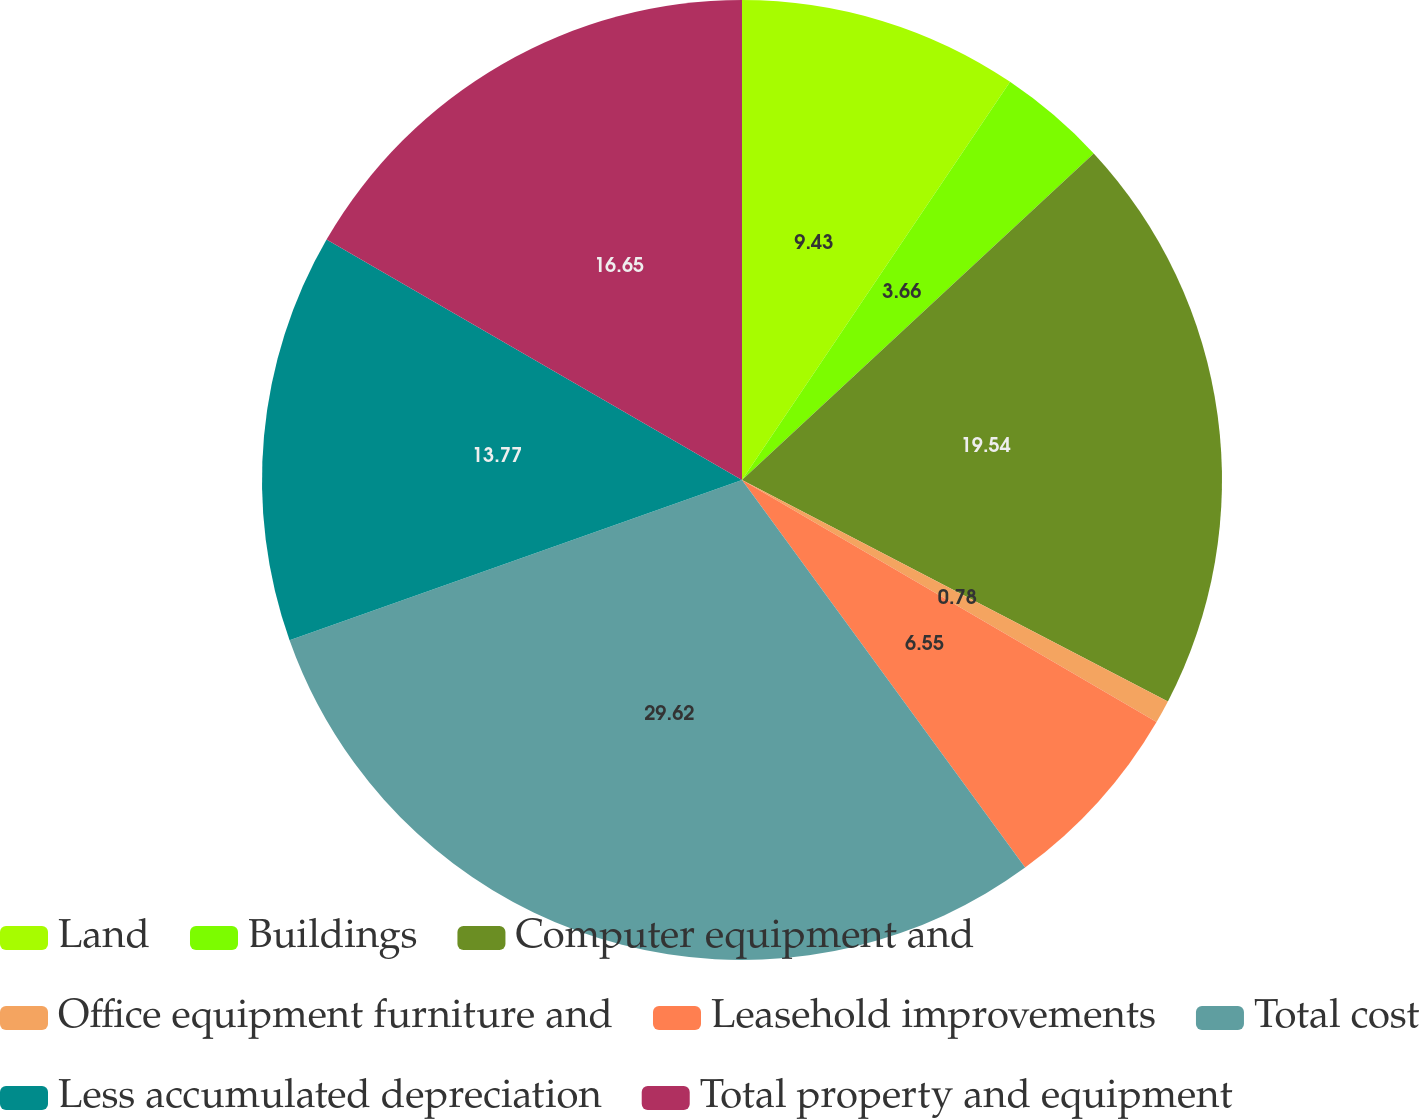Convert chart to OTSL. <chart><loc_0><loc_0><loc_500><loc_500><pie_chart><fcel>Land<fcel>Buildings<fcel>Computer equipment and<fcel>Office equipment furniture and<fcel>Leasehold improvements<fcel>Total cost<fcel>Less accumulated depreciation<fcel>Total property and equipment<nl><fcel>9.43%<fcel>3.66%<fcel>19.54%<fcel>0.78%<fcel>6.55%<fcel>29.62%<fcel>13.77%<fcel>16.65%<nl></chart> 